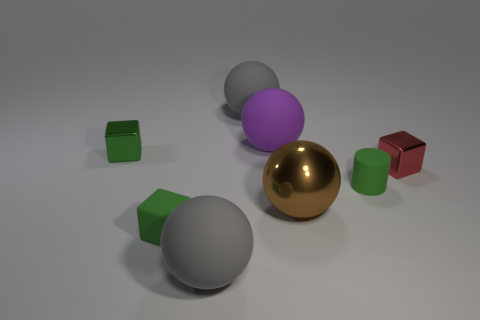The rubber object that is the same color as the tiny matte cube is what shape?
Ensure brevity in your answer.  Cylinder. Is there another matte cube that has the same size as the red cube?
Your response must be concise. Yes. There is a matte ball in front of the large brown metallic thing; what is its size?
Give a very brief answer. Large. What color is the metal block to the left of the tiny shiny object right of the metallic object to the left of the small matte block?
Offer a terse response. Green. The tiny shiny block on the right side of the gray rubber sphere that is in front of the tiny rubber block is what color?
Your response must be concise. Red. Is the number of small matte things behind the small green matte cube greater than the number of small green cubes that are to the right of the large purple matte thing?
Your answer should be compact. Yes. Is the block that is in front of the brown ball made of the same material as the gray object that is in front of the green metallic object?
Provide a succinct answer. Yes. There is a big purple matte object; are there any shiny cubes to the right of it?
Give a very brief answer. Yes. What number of green objects are either small rubber things or small shiny cubes?
Ensure brevity in your answer.  3. Are the big purple sphere and the gray object that is in front of the small red metal block made of the same material?
Your answer should be very brief. Yes. 